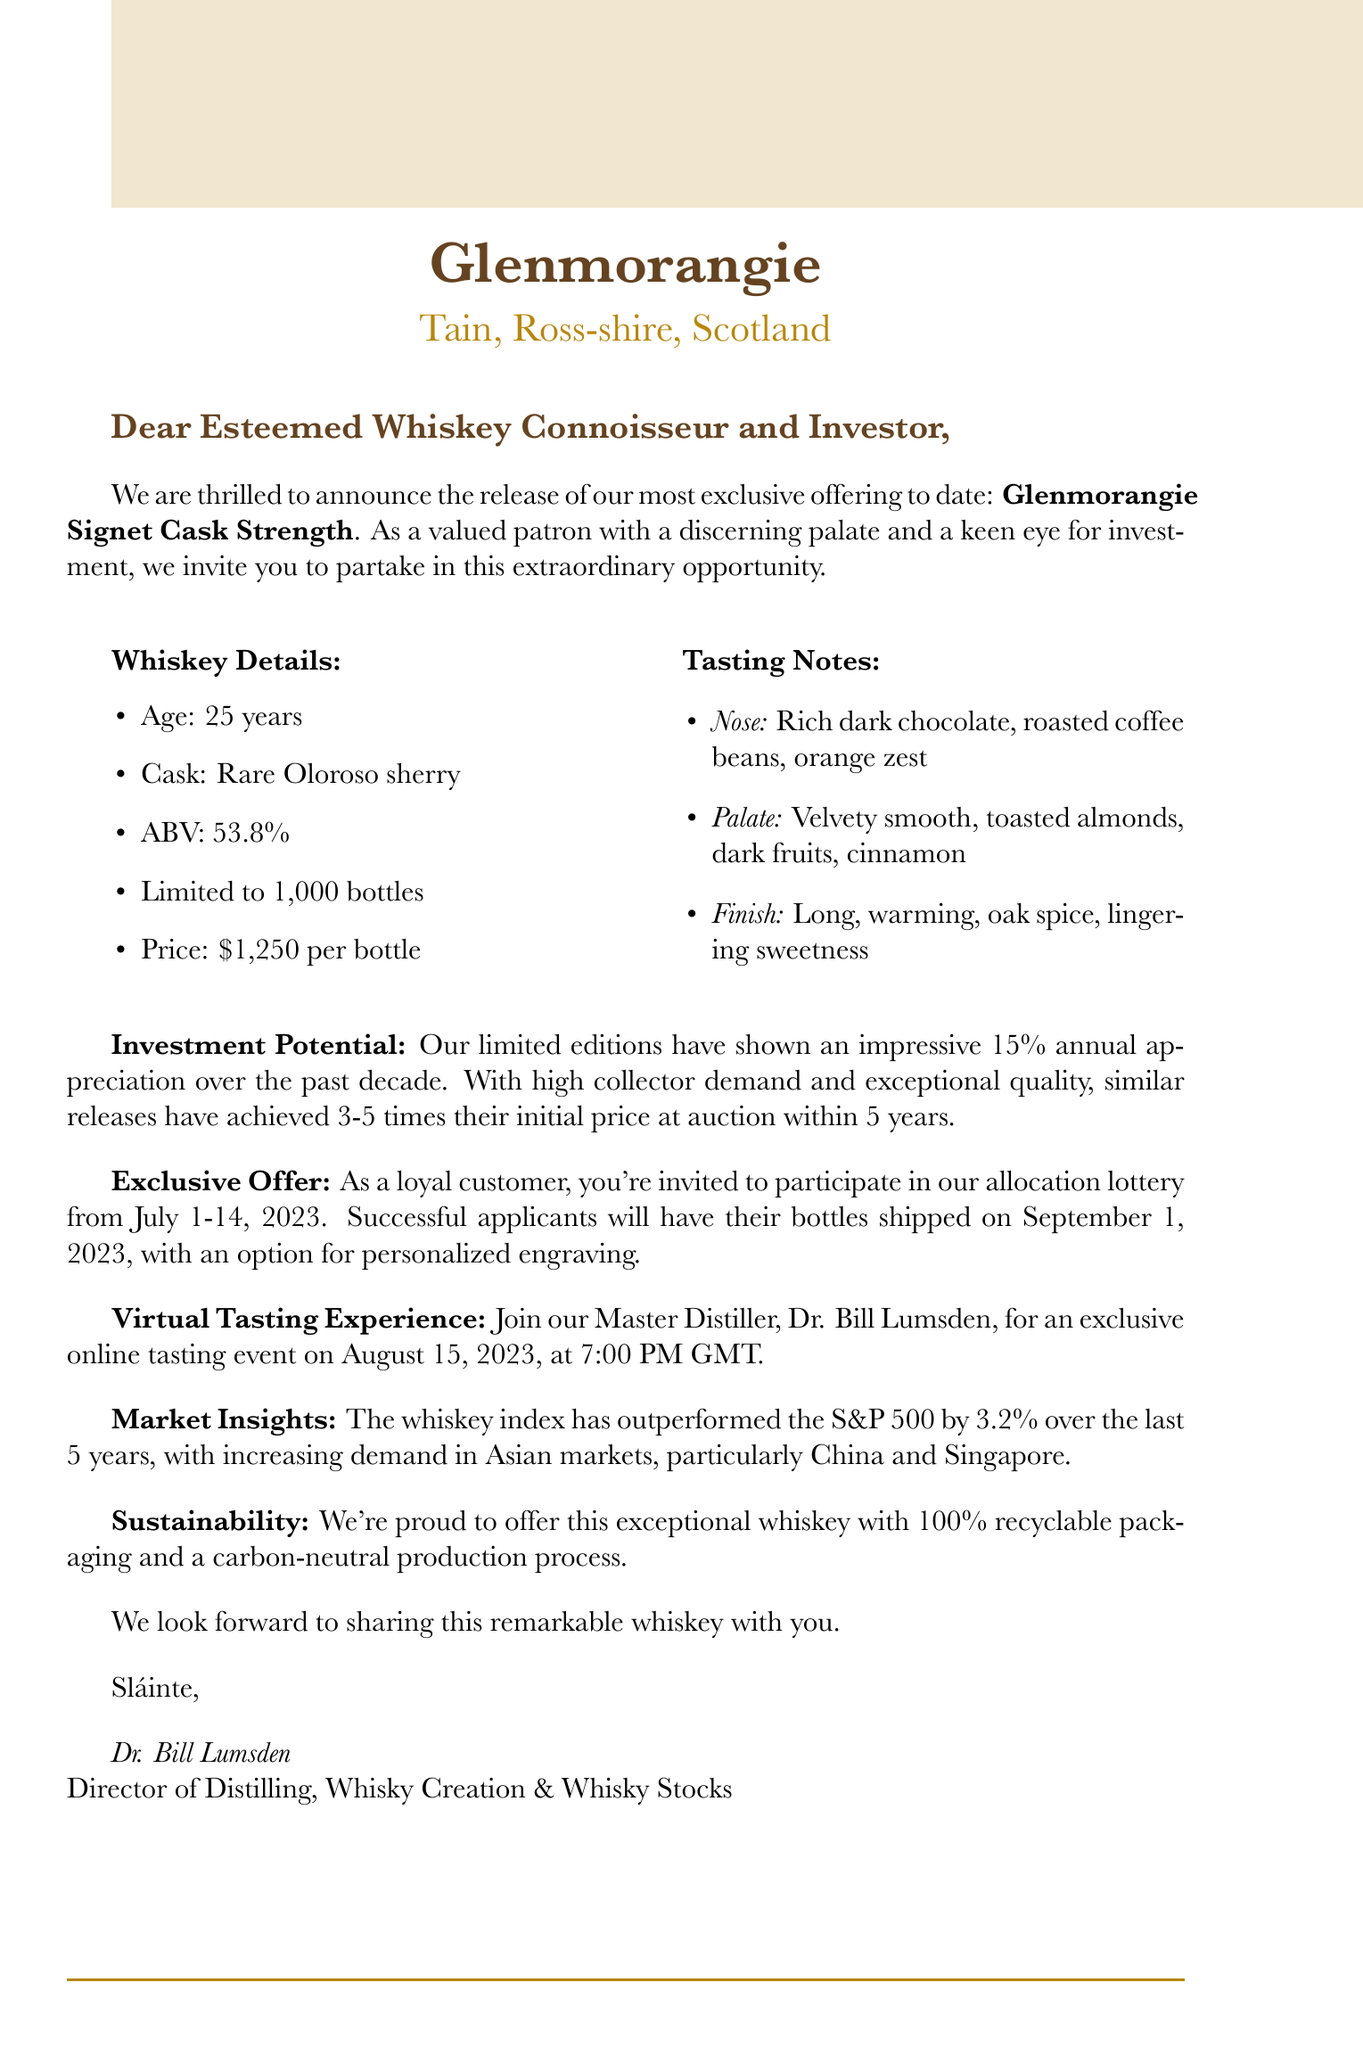What is the distillery name? The distillery name is mentioned at the beginning of the document.
Answer: Glenmorangie Where is the distillery located? The location of the distillery is specified below the name.
Answer: Tain, Ross-shire, Scotland What is the age of the whiskey? The age of the whiskey is provided in the whiskey details section.
Answer: 25 years How many bottles are available for this release? The document states the number of bottles in the whiskey details section.
Answer: 1,000 What is the price per bottle? The price of the whiskey is outlined in the whiskey details section.
Answer: $1,250 per bottle What is the ABV of the Glenmorangie Signet Cask Strength? The ABV is specified in the whiskey details section of the document.
Answer: 53.8% What is the method for bottle allocation? The allocation method for this whiskey is detailed in the exclusive offer.
Answer: Lottery system What is the date of the virtual tasting experience? The date for the exclusive online tasting event is listed in the document.
Answer: August 15, 2023 How has the whiskey index performed compared to the S&P 500? The comparative performance is explained in the market insights section.
Answer: Outperformed by 3.2% 